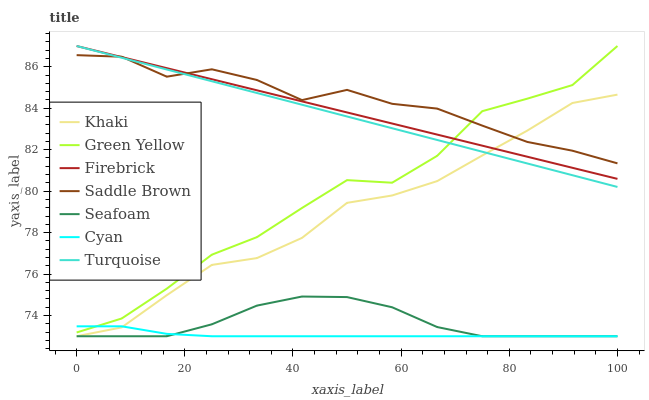Does Cyan have the minimum area under the curve?
Answer yes or no. Yes. Does Saddle Brown have the maximum area under the curve?
Answer yes or no. Yes. Does Khaki have the minimum area under the curve?
Answer yes or no. No. Does Khaki have the maximum area under the curve?
Answer yes or no. No. Is Turquoise the smoothest?
Answer yes or no. Yes. Is Green Yellow the roughest?
Answer yes or no. Yes. Is Khaki the smoothest?
Answer yes or no. No. Is Khaki the roughest?
Answer yes or no. No. Does Firebrick have the lowest value?
Answer yes or no. No. Does Green Yellow have the highest value?
Answer yes or no. Yes. Does Khaki have the highest value?
Answer yes or no. No. Is Cyan less than Turquoise?
Answer yes or no. Yes. Is Turquoise greater than Cyan?
Answer yes or no. Yes. Does Cyan intersect Turquoise?
Answer yes or no. No. 